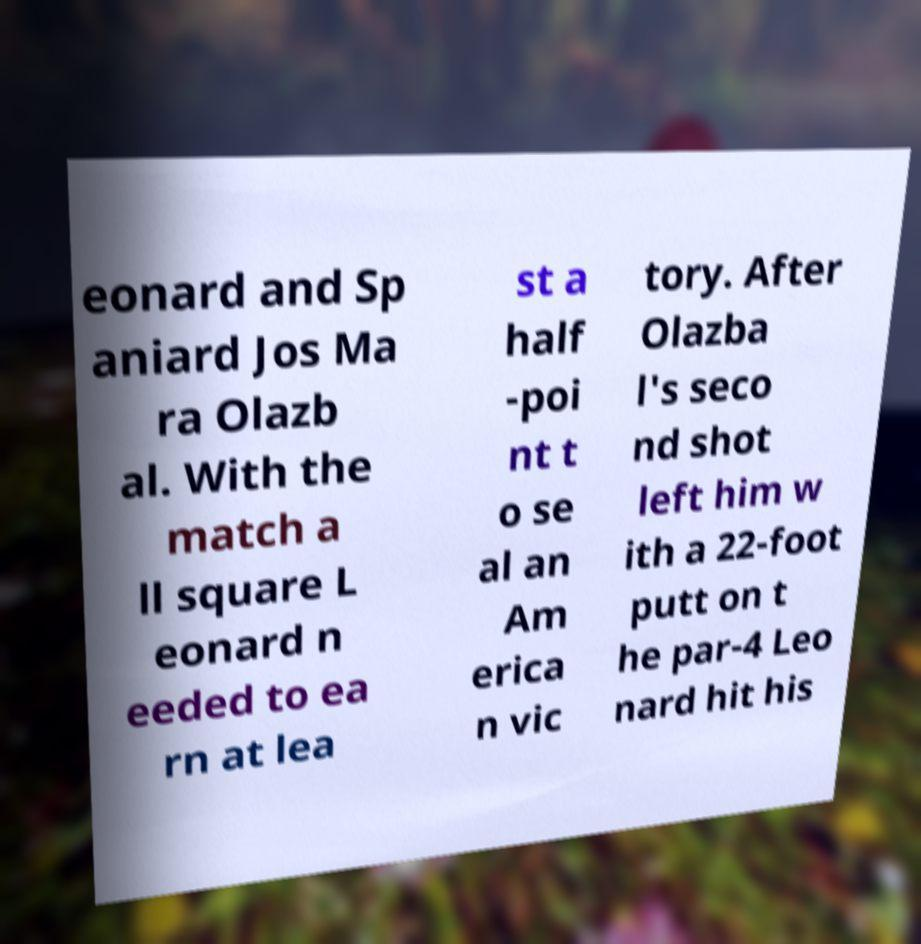Could you assist in decoding the text presented in this image and type it out clearly? eonard and Sp aniard Jos Ma ra Olazb al. With the match a ll square L eonard n eeded to ea rn at lea st a half -poi nt t o se al an Am erica n vic tory. After Olazba l's seco nd shot left him w ith a 22-foot putt on t he par-4 Leo nard hit his 